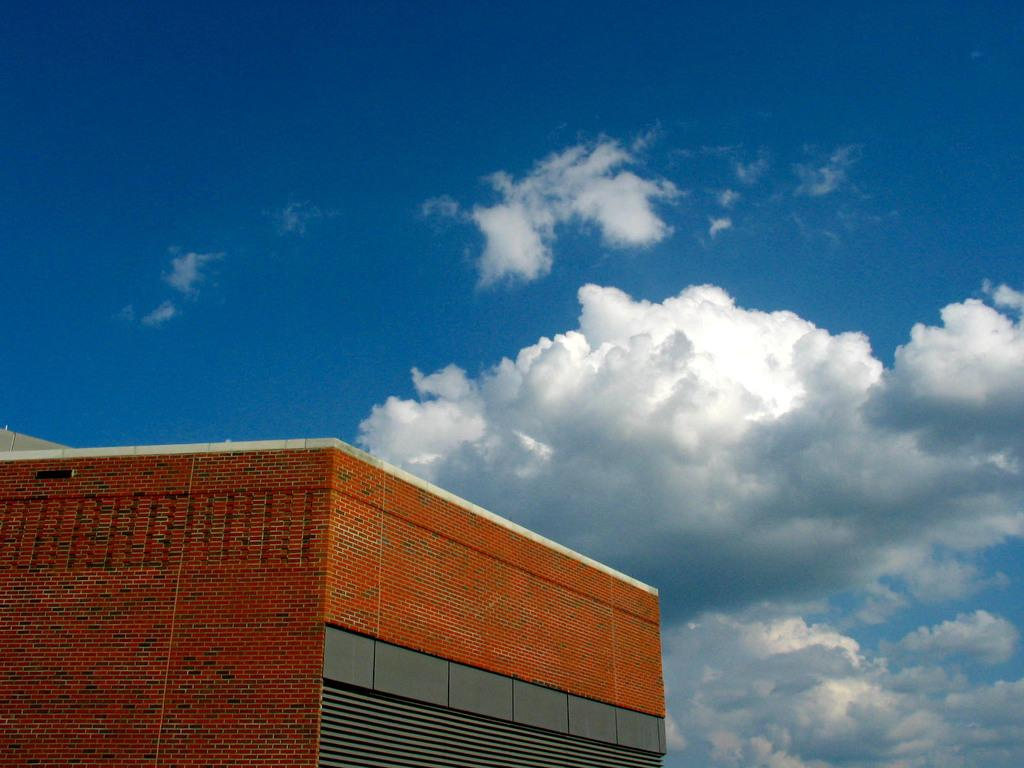What is the main structure in the image? There is a building in the image. What can be seen in the background of the image? The sky is visible in the background of the image. How would you describe the sky in the image? The sky appears to be cloudy. What type of brass pot can be seen in the image? There is no brass pot present in the image. What is the rate of the building's growth in the image? The image does not depict the building's growth, so it is not possible to determine its rate. 